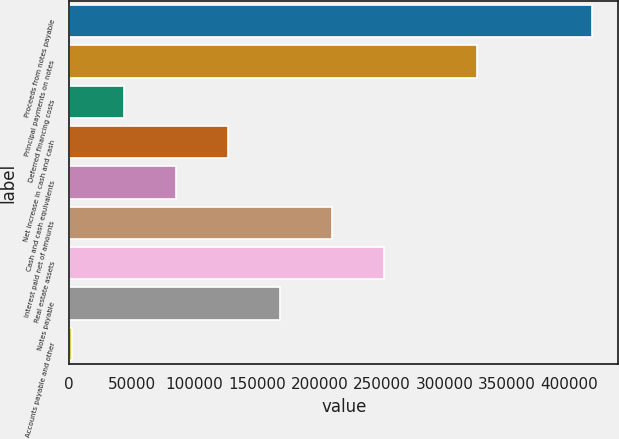Convert chart. <chart><loc_0><loc_0><loc_500><loc_500><bar_chart><fcel>Proceeds from notes payable<fcel>Principal payments on notes<fcel>Deferred financing costs<fcel>Net increase in cash and cash<fcel>Cash and cash equivalents<fcel>Interest paid net of amounts<fcel>Real estate assets<fcel>Notes payable<fcel>Accounts payable and other<nl><fcel>418154<fcel>325917<fcel>43740.5<fcel>126944<fcel>85342<fcel>210146<fcel>251748<fcel>168545<fcel>2139<nl></chart> 